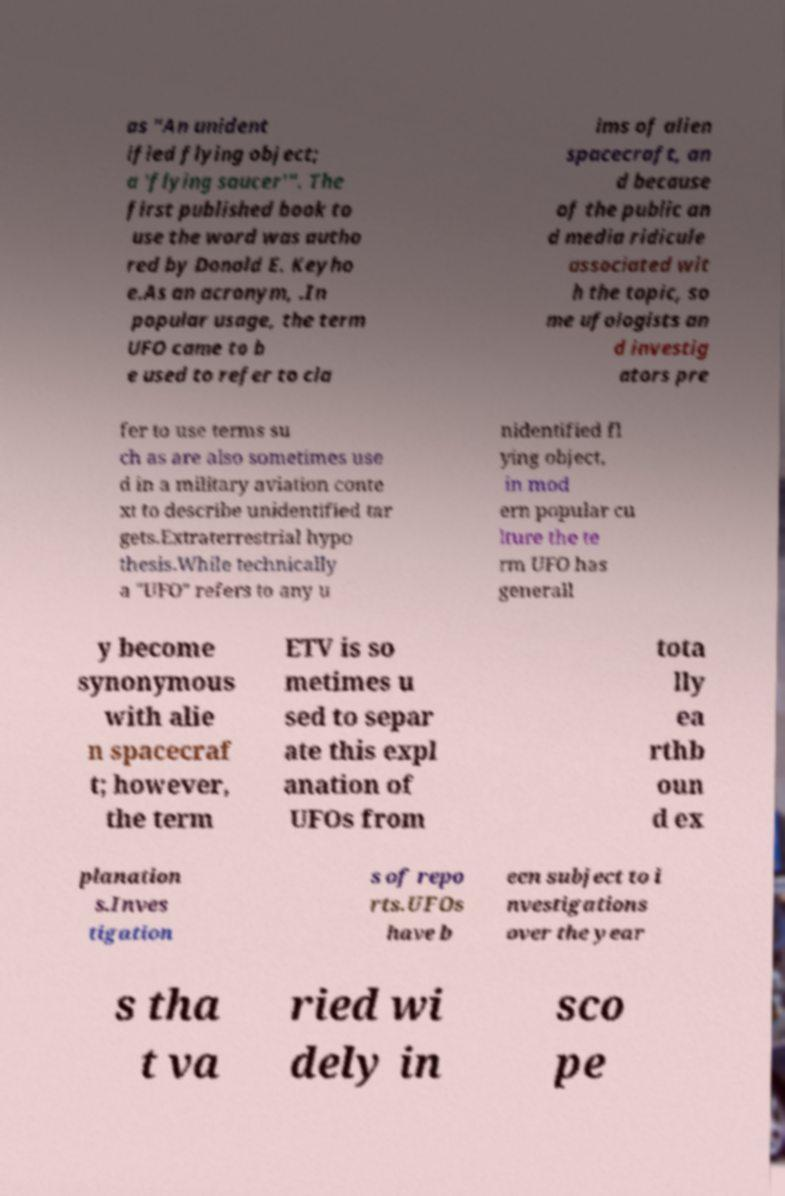There's text embedded in this image that I need extracted. Can you transcribe it verbatim? as "An unident ified flying object; a 'flying saucer'". The first published book to use the word was autho red by Donald E. Keyho e.As an acronym, .In popular usage, the term UFO came to b e used to refer to cla ims of alien spacecraft, an d because of the public an d media ridicule associated wit h the topic, so me ufologists an d investig ators pre fer to use terms su ch as are also sometimes use d in a military aviation conte xt to describe unidentified tar gets.Extraterrestrial hypo thesis.While technically a "UFO" refers to any u nidentified fl ying object, in mod ern popular cu lture the te rm UFO has generall y become synonymous with alie n spacecraf t; however, the term ETV is so metimes u sed to separ ate this expl anation of UFOs from tota lly ea rthb oun d ex planation s.Inves tigation s of repo rts.UFOs have b een subject to i nvestigations over the year s tha t va ried wi dely in sco pe 